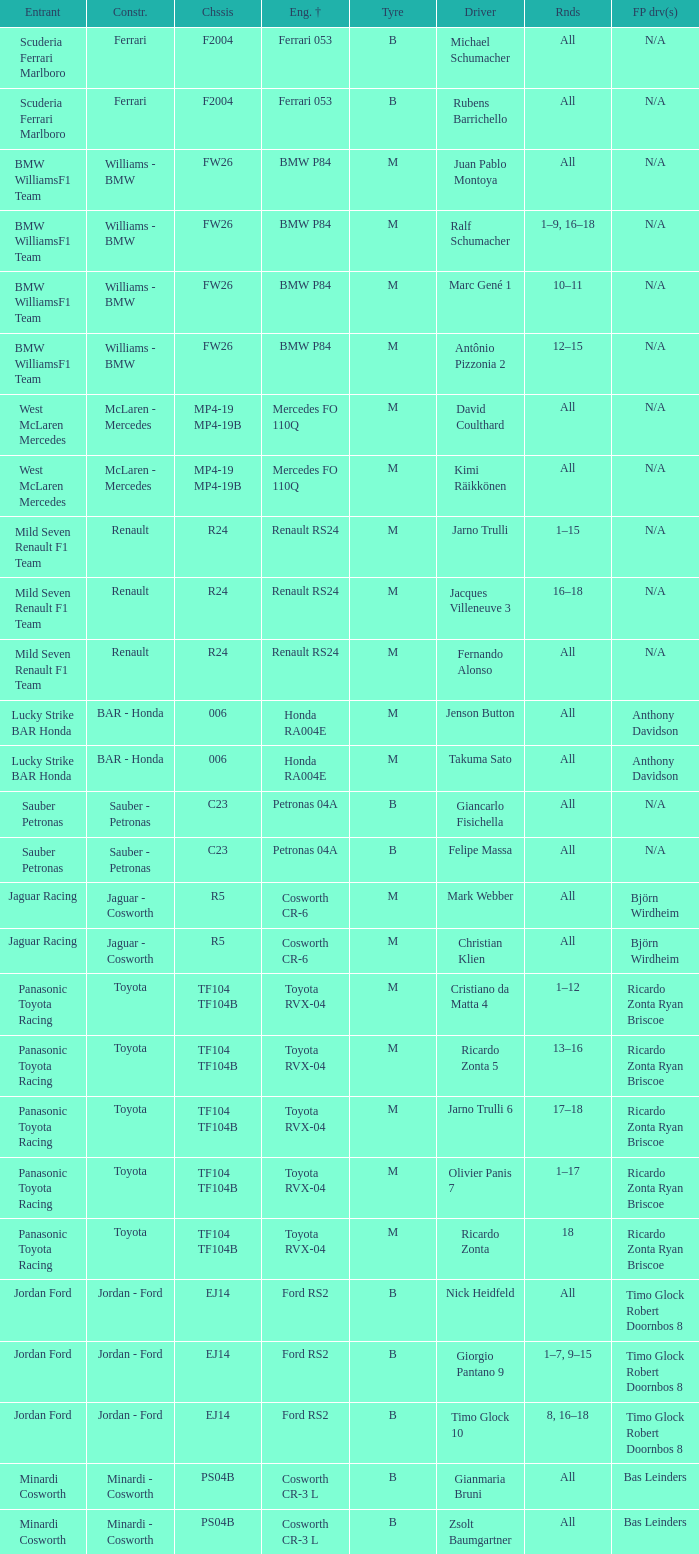What kind of free practice is there with a Ford RS2 engine +? Timo Glock Robert Doornbos 8, Timo Glock Robert Doornbos 8, Timo Glock Robert Doornbos 8. 